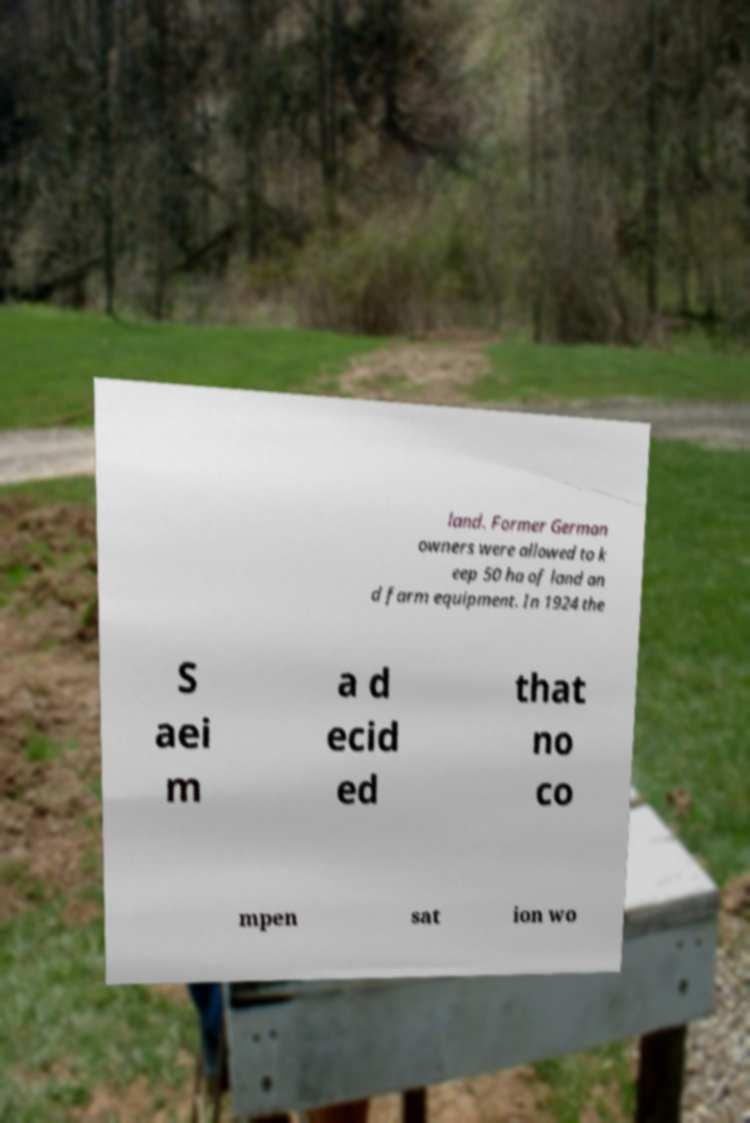Could you extract and type out the text from this image? land. Former German owners were allowed to k eep 50 ha of land an d farm equipment. In 1924 the S aei m a d ecid ed that no co mpen sat ion wo 